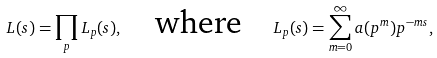<formula> <loc_0><loc_0><loc_500><loc_500>L ( s ) = \prod _ { p } L _ { p } ( s ) , \quad \text {where} \quad L _ { p } ( s ) = \sum _ { m = 0 } ^ { \infty } a ( p ^ { m } ) p ^ { - m s } ,</formula> 